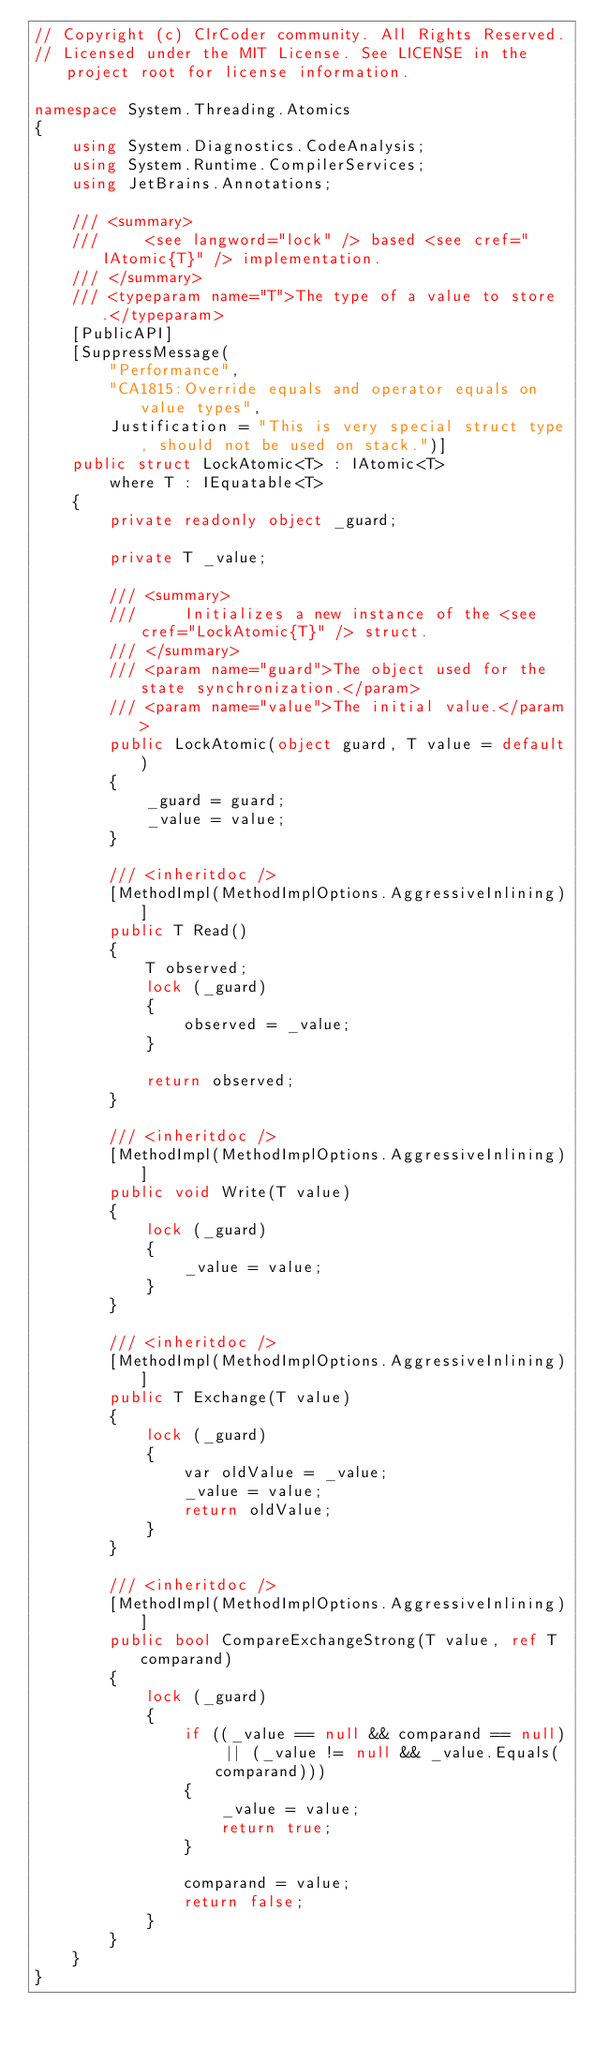<code> <loc_0><loc_0><loc_500><loc_500><_C#_>// Copyright (c) ClrCoder community. All Rights Reserved.
// Licensed under the MIT License. See LICENSE in the project root for license information.

namespace System.Threading.Atomics
{
    using System.Diagnostics.CodeAnalysis;
    using System.Runtime.CompilerServices;
    using JetBrains.Annotations;

    /// <summary>
    ///     <see langword="lock" /> based <see cref="IAtomic{T}" /> implementation.
    /// </summary>
    /// <typeparam name="T">The type of a value to store.</typeparam>
    [PublicAPI]
    [SuppressMessage(
        "Performance",
        "CA1815:Override equals and operator equals on value types",
        Justification = "This is very special struct type, should not be used on stack.")]
    public struct LockAtomic<T> : IAtomic<T>
        where T : IEquatable<T>
    {
        private readonly object _guard;

        private T _value;

        /// <summary>
        ///     Initializes a new instance of the <see cref="LockAtomic{T}" /> struct.
        /// </summary>
        /// <param name="guard">The object used for the state synchronization.</param>
        /// <param name="value">The initial value.</param>
        public LockAtomic(object guard, T value = default)
        {
            _guard = guard;
            _value = value;
        }

        /// <inheritdoc />
        [MethodImpl(MethodImplOptions.AggressiveInlining)]
        public T Read()
        {
            T observed;
            lock (_guard)
            {
                observed = _value;
            }

            return observed;
        }

        /// <inheritdoc />
        [MethodImpl(MethodImplOptions.AggressiveInlining)]
        public void Write(T value)
        {
            lock (_guard)
            {
                _value = value;
            }
        }

        /// <inheritdoc />
        [MethodImpl(MethodImplOptions.AggressiveInlining)]
        public T Exchange(T value)
        {
            lock (_guard)
            {
                var oldValue = _value;
                _value = value;
                return oldValue;
            }
        }

        /// <inheritdoc />
        [MethodImpl(MethodImplOptions.AggressiveInlining)]
        public bool CompareExchangeStrong(T value, ref T comparand)
        {
            lock (_guard)
            {
                if ((_value == null && comparand == null) || (_value != null && _value.Equals(comparand)))
                {
                    _value = value;
                    return true;
                }

                comparand = value;
                return false;
            }
        }
    }
}
</code> 